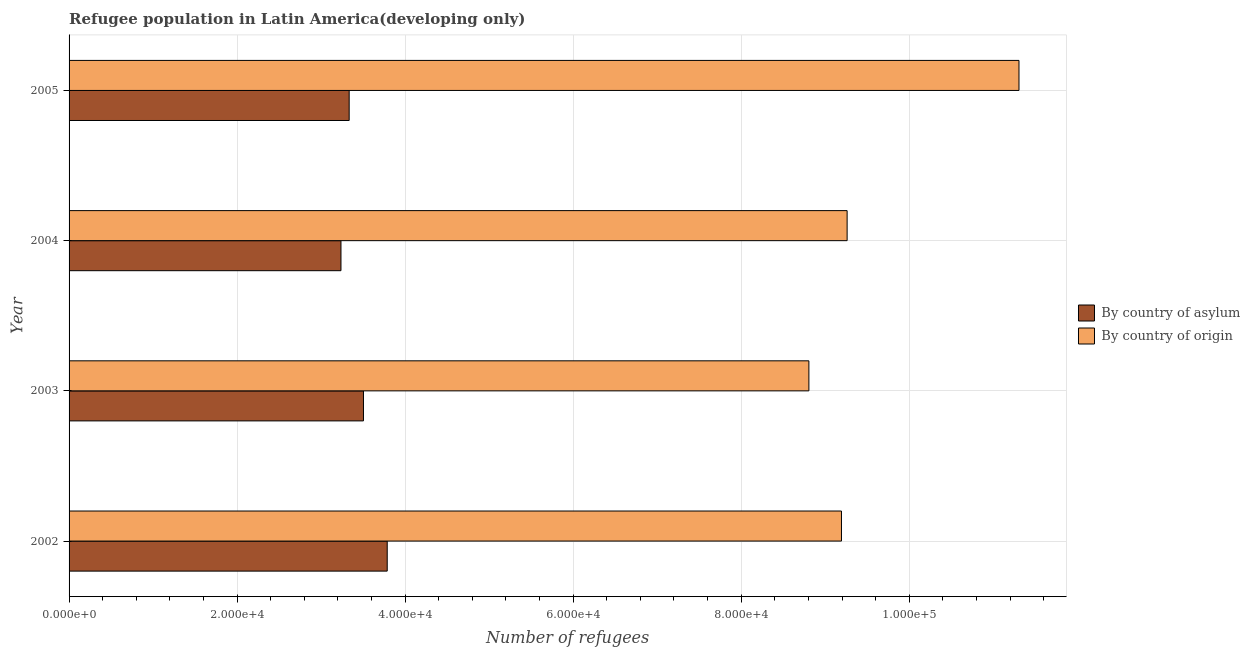How many different coloured bars are there?
Give a very brief answer. 2. Are the number of bars per tick equal to the number of legend labels?
Your response must be concise. Yes. Are the number of bars on each tick of the Y-axis equal?
Your response must be concise. Yes. How many bars are there on the 1st tick from the top?
Offer a terse response. 2. How many bars are there on the 1st tick from the bottom?
Provide a succinct answer. 2. What is the number of refugees by country of asylum in 2002?
Ensure brevity in your answer.  3.79e+04. Across all years, what is the maximum number of refugees by country of origin?
Your answer should be compact. 1.13e+05. Across all years, what is the minimum number of refugees by country of asylum?
Make the answer very short. 3.24e+04. In which year was the number of refugees by country of origin maximum?
Your answer should be compact. 2005. In which year was the number of refugees by country of origin minimum?
Provide a short and direct response. 2003. What is the total number of refugees by country of asylum in the graph?
Your response must be concise. 1.39e+05. What is the difference between the number of refugees by country of asylum in 2002 and that in 2005?
Offer a very short reply. 4529. What is the difference between the number of refugees by country of origin in 2004 and the number of refugees by country of asylum in 2005?
Make the answer very short. 5.93e+04. What is the average number of refugees by country of origin per year?
Your answer should be very brief. 9.64e+04. In the year 2002, what is the difference between the number of refugees by country of asylum and number of refugees by country of origin?
Your answer should be very brief. -5.41e+04. What is the ratio of the number of refugees by country of asylum in 2003 to that in 2004?
Give a very brief answer. 1.08. What is the difference between the highest and the second highest number of refugees by country of origin?
Ensure brevity in your answer.  2.05e+04. What is the difference between the highest and the lowest number of refugees by country of asylum?
Offer a terse response. 5505. In how many years, is the number of refugees by country of asylum greater than the average number of refugees by country of asylum taken over all years?
Keep it short and to the point. 2. Is the sum of the number of refugees by country of asylum in 2003 and 2004 greater than the maximum number of refugees by country of origin across all years?
Ensure brevity in your answer.  No. What does the 1st bar from the top in 2005 represents?
Your answer should be compact. By country of origin. What does the 1st bar from the bottom in 2003 represents?
Your answer should be compact. By country of asylum. What is the difference between two consecutive major ticks on the X-axis?
Give a very brief answer. 2.00e+04. Where does the legend appear in the graph?
Make the answer very short. Center right. What is the title of the graph?
Offer a very short reply. Refugee population in Latin America(developing only). What is the label or title of the X-axis?
Make the answer very short. Number of refugees. What is the label or title of the Y-axis?
Provide a succinct answer. Year. What is the Number of refugees of By country of asylum in 2002?
Ensure brevity in your answer.  3.79e+04. What is the Number of refugees in By country of origin in 2002?
Offer a very short reply. 9.19e+04. What is the Number of refugees of By country of asylum in 2003?
Your answer should be very brief. 3.50e+04. What is the Number of refugees of By country of origin in 2003?
Provide a short and direct response. 8.81e+04. What is the Number of refugees in By country of asylum in 2004?
Offer a terse response. 3.24e+04. What is the Number of refugees in By country of origin in 2004?
Give a very brief answer. 9.26e+04. What is the Number of refugees in By country of asylum in 2005?
Your answer should be very brief. 3.33e+04. What is the Number of refugees in By country of origin in 2005?
Make the answer very short. 1.13e+05. Across all years, what is the maximum Number of refugees in By country of asylum?
Your answer should be very brief. 3.79e+04. Across all years, what is the maximum Number of refugees of By country of origin?
Give a very brief answer. 1.13e+05. Across all years, what is the minimum Number of refugees in By country of asylum?
Make the answer very short. 3.24e+04. Across all years, what is the minimum Number of refugees of By country of origin?
Keep it short and to the point. 8.81e+04. What is the total Number of refugees of By country of asylum in the graph?
Ensure brevity in your answer.  1.39e+05. What is the total Number of refugees in By country of origin in the graph?
Provide a succinct answer. 3.86e+05. What is the difference between the Number of refugees of By country of asylum in 2002 and that in 2003?
Keep it short and to the point. 2827. What is the difference between the Number of refugees in By country of origin in 2002 and that in 2003?
Keep it short and to the point. 3878. What is the difference between the Number of refugees of By country of asylum in 2002 and that in 2004?
Keep it short and to the point. 5505. What is the difference between the Number of refugees of By country of origin in 2002 and that in 2004?
Offer a terse response. -673. What is the difference between the Number of refugees in By country of asylum in 2002 and that in 2005?
Your answer should be compact. 4529. What is the difference between the Number of refugees in By country of origin in 2002 and that in 2005?
Provide a short and direct response. -2.11e+04. What is the difference between the Number of refugees of By country of asylum in 2003 and that in 2004?
Offer a terse response. 2678. What is the difference between the Number of refugees of By country of origin in 2003 and that in 2004?
Your response must be concise. -4551. What is the difference between the Number of refugees in By country of asylum in 2003 and that in 2005?
Ensure brevity in your answer.  1702. What is the difference between the Number of refugees in By country of origin in 2003 and that in 2005?
Provide a short and direct response. -2.50e+04. What is the difference between the Number of refugees in By country of asylum in 2004 and that in 2005?
Provide a succinct answer. -976. What is the difference between the Number of refugees of By country of origin in 2004 and that in 2005?
Your answer should be compact. -2.05e+04. What is the difference between the Number of refugees in By country of asylum in 2002 and the Number of refugees in By country of origin in 2003?
Ensure brevity in your answer.  -5.02e+04. What is the difference between the Number of refugees in By country of asylum in 2002 and the Number of refugees in By country of origin in 2004?
Provide a short and direct response. -5.47e+04. What is the difference between the Number of refugees in By country of asylum in 2002 and the Number of refugees in By country of origin in 2005?
Ensure brevity in your answer.  -7.52e+04. What is the difference between the Number of refugees in By country of asylum in 2003 and the Number of refugees in By country of origin in 2004?
Ensure brevity in your answer.  -5.76e+04. What is the difference between the Number of refugees in By country of asylum in 2003 and the Number of refugees in By country of origin in 2005?
Give a very brief answer. -7.80e+04. What is the difference between the Number of refugees in By country of asylum in 2004 and the Number of refugees in By country of origin in 2005?
Keep it short and to the point. -8.07e+04. What is the average Number of refugees in By country of asylum per year?
Your answer should be very brief. 3.47e+04. What is the average Number of refugees in By country of origin per year?
Your answer should be very brief. 9.64e+04. In the year 2002, what is the difference between the Number of refugees of By country of asylum and Number of refugees of By country of origin?
Provide a succinct answer. -5.41e+04. In the year 2003, what is the difference between the Number of refugees of By country of asylum and Number of refugees of By country of origin?
Provide a short and direct response. -5.30e+04. In the year 2004, what is the difference between the Number of refugees in By country of asylum and Number of refugees in By country of origin?
Ensure brevity in your answer.  -6.02e+04. In the year 2005, what is the difference between the Number of refugees of By country of asylum and Number of refugees of By country of origin?
Your answer should be very brief. -7.97e+04. What is the ratio of the Number of refugees in By country of asylum in 2002 to that in 2003?
Ensure brevity in your answer.  1.08. What is the ratio of the Number of refugees in By country of origin in 2002 to that in 2003?
Your answer should be very brief. 1.04. What is the ratio of the Number of refugees in By country of asylum in 2002 to that in 2004?
Provide a succinct answer. 1.17. What is the ratio of the Number of refugees of By country of origin in 2002 to that in 2004?
Give a very brief answer. 0.99. What is the ratio of the Number of refugees of By country of asylum in 2002 to that in 2005?
Your answer should be compact. 1.14. What is the ratio of the Number of refugees of By country of origin in 2002 to that in 2005?
Give a very brief answer. 0.81. What is the ratio of the Number of refugees of By country of asylum in 2003 to that in 2004?
Your answer should be very brief. 1.08. What is the ratio of the Number of refugees of By country of origin in 2003 to that in 2004?
Provide a short and direct response. 0.95. What is the ratio of the Number of refugees of By country of asylum in 2003 to that in 2005?
Provide a succinct answer. 1.05. What is the ratio of the Number of refugees in By country of origin in 2003 to that in 2005?
Give a very brief answer. 0.78. What is the ratio of the Number of refugees in By country of asylum in 2004 to that in 2005?
Your answer should be very brief. 0.97. What is the ratio of the Number of refugees in By country of origin in 2004 to that in 2005?
Your response must be concise. 0.82. What is the difference between the highest and the second highest Number of refugees in By country of asylum?
Offer a very short reply. 2827. What is the difference between the highest and the second highest Number of refugees in By country of origin?
Your answer should be very brief. 2.05e+04. What is the difference between the highest and the lowest Number of refugees in By country of asylum?
Ensure brevity in your answer.  5505. What is the difference between the highest and the lowest Number of refugees in By country of origin?
Offer a terse response. 2.50e+04. 